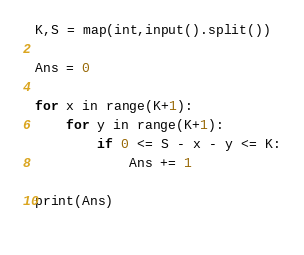<code> <loc_0><loc_0><loc_500><loc_500><_Python_>K,S = map(int,input().split())

Ans = 0

for x in range(K+1):
	for y in range(K+1):
		if 0 <= S - x - y <= K:
			Ans += 1

print(Ans)
	</code> 